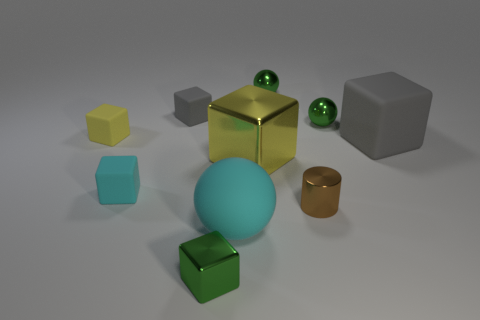Subtract all tiny green metallic blocks. How many blocks are left? 5 Subtract all cyan balls. How many balls are left? 2 Subtract all blue cubes. How many green balls are left? 2 Subtract all balls. How many objects are left? 7 Subtract 1 cubes. How many cubes are left? 5 Subtract all purple balls. Subtract all green blocks. How many balls are left? 3 Subtract all blue spheres. Subtract all tiny yellow rubber objects. How many objects are left? 9 Add 5 big cyan objects. How many big cyan objects are left? 6 Add 9 blue shiny balls. How many blue shiny balls exist? 9 Subtract 0 yellow spheres. How many objects are left? 10 